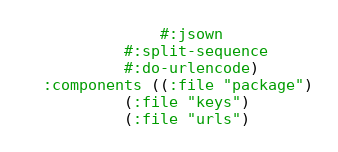Convert code to text. <code><loc_0><loc_0><loc_500><loc_500><_Lisp_>               #:jsown
	       #:split-sequence
	       #:do-urlencode)
  :components ((:file "package")
	       (:file "keys")
	       (:file "urls")</code> 